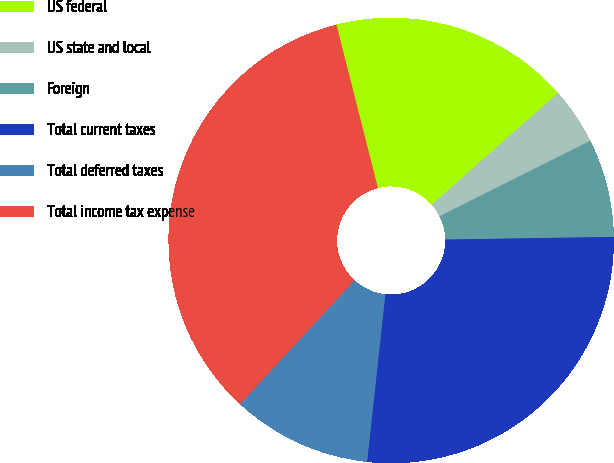Convert chart to OTSL. <chart><loc_0><loc_0><loc_500><loc_500><pie_chart><fcel>US federal<fcel>US state and local<fcel>Foreign<fcel>Total current taxes<fcel>Total deferred taxes<fcel>Total income tax expense<nl><fcel>17.44%<fcel>4.13%<fcel>7.13%<fcel>26.98%<fcel>10.14%<fcel>34.18%<nl></chart> 